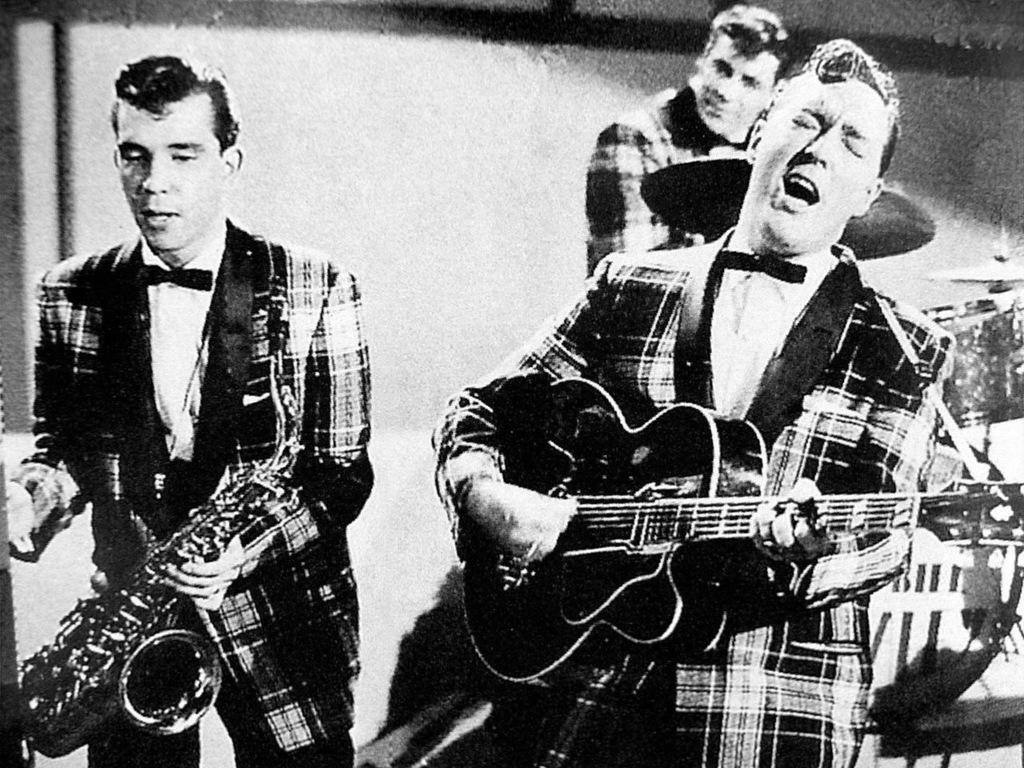Who or what is present in the image? There are people in the image. What are the people doing in the image? The people are standing and holding musical instruments. What is the color scheme of the image? The image is in black and white. What type of scarf is being worn by the person playing the guitar in the image? There is no scarf visible in the image, as the people are holding musical instruments and not wearing any accessories. 